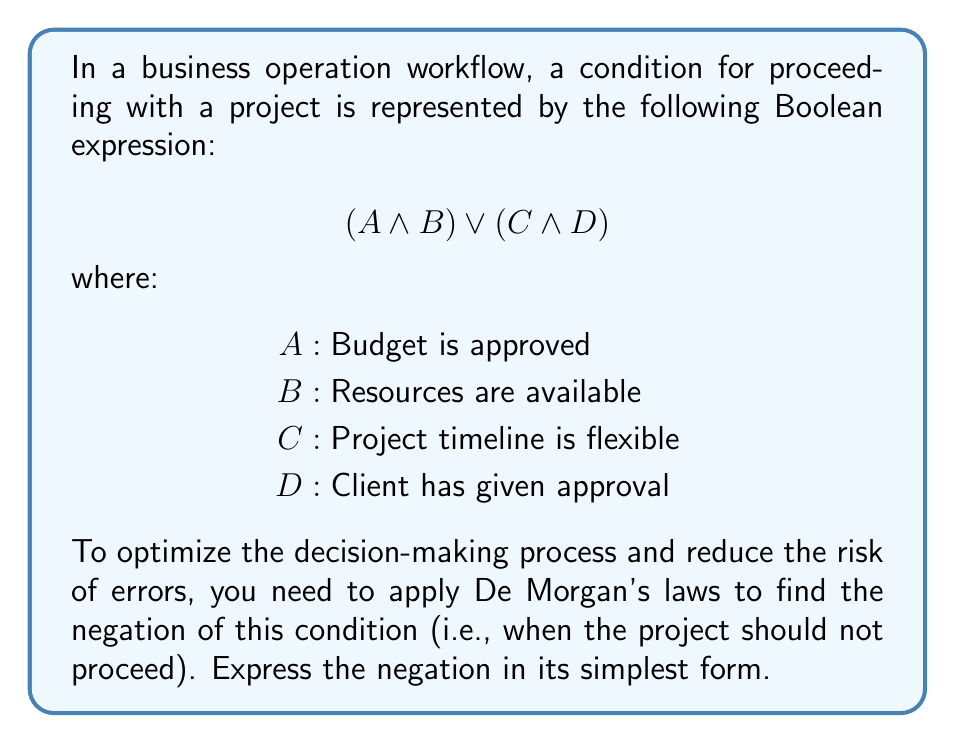What is the answer to this math problem? Let's approach this step-by-step:

1) First, we need to negate the entire expression. The negation of $(A \land B) \lor (C \land D)$ is:

   $\neg((A \land B) \lor (C \land D))$

2) Now, we can apply De Morgan's first law to this expression. This law states that the negation of a disjunction is the conjunction of the negations:

   $\neg(P \lor Q) \equiv \neg P \land \neg Q$

   Applying this to our expression:

   $\neg((A \land B) \lor (C \land D)) \equiv \neg(A \land B) \land \neg(C \land D)$

3) Now we can apply De Morgan's second law to each of the conjunctions inside the parentheses. This law states that the negation of a conjunction is the disjunction of the negations:

   $\neg(P \land Q) \equiv \neg P \lor \neg Q$

   Applying this to both $(A \land B)$ and $(C \land D)$:

   $(\neg A \lor \neg B) \land (\neg C \lor \neg D)$

4) This is the simplest form of the negation. In terms of our original variables, it means the project should not proceed when:
   - Either the budget is not approved OR resources are not available, AND
   - Either the project timeline is not flexible OR the client has not given approval

This simplified logical condition streamlines the decision-making process by clearly defining when a project should not proceed, thus enhancing operational efficiency and risk management.
Answer: $(\neg A \lor \neg B) \land (\neg C \lor \neg D)$ 